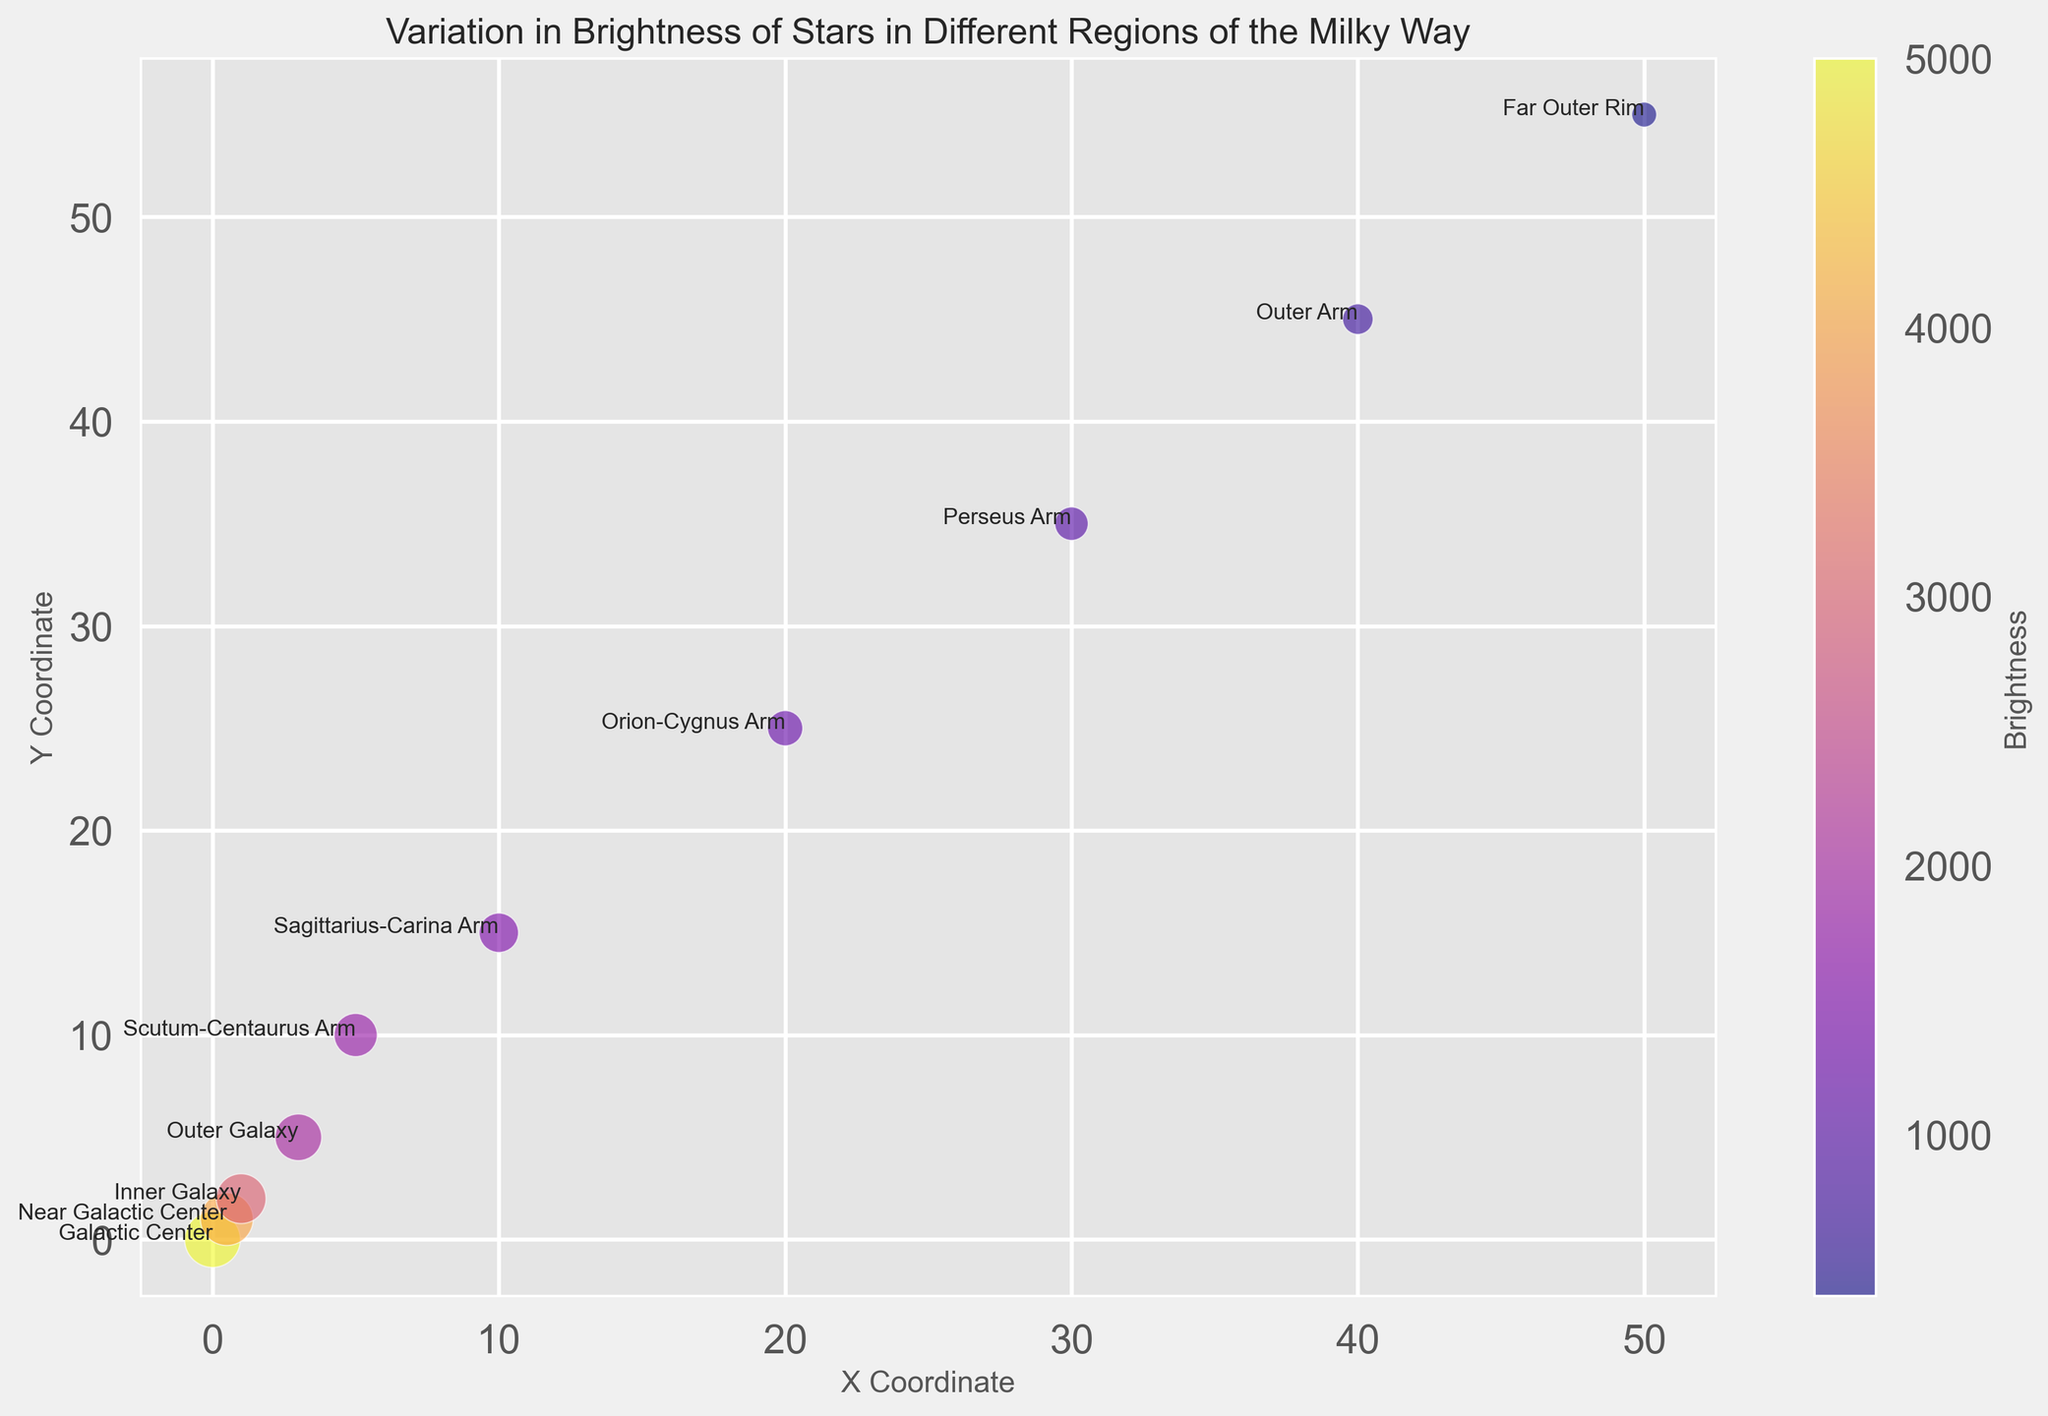Which region has the highest brightness? To find the region with the highest brightness, look for the region where the 'brightness' variable is at its maximum value. From the plot, the brightness is highest at the Galactic Center, which is at the center of the chart.
Answer: Galactic Center Which region occupies the largest bubble on the chart? The size of the bubble is proportional to the 'size' column. Locate the largest bubble visually on the chart, which corresponds to the largest star size. The largest bubble is at the Galactic Center (center of the chart).
Answer: Galactic Center How does the brightness of stars change as you move from the Galactic Center to the Far Outer Rim? Observe the colors of the bubbles as you move from the Galactic Center to the Far Outer Rim. The colors shift from a bright yellow (high brightness) at the Galactic Center to darker colors (lower brightness) at the Far Outer Rim. This indicates a decrease in brightness.
Answer: Decreases Compare the brightness of stars between the Inner Galaxy and the Scutum-Centaurus Arm. Which is brighter? Find the Inner Galaxy and the Scutum-Centaurus Arm on the chart. Compare their colors; the Inner Galaxy has a brighter color (higher brightness of 3000) compared to the Scutum-Centaurus Arm (brightness of 1800).
Answer: Inner Galaxy What is the average brightness of stars in the Scutum-Centaurus Arm and the Sagittarius-Carina Arm? The brightness values for the Scutum-Centaurus Arm and the Sagittarius-Carina Arm are 1800 and 1500, respectively. Calculate the average: (1800 + 1500) / 2 = 1650.
Answer: 1650 Which region is farthest from the Galactic Center in terms of x and y coordinates? To find the region farthest from the Galactic Center, look for the bubble with the highest x and y coordinates. The Far Outer Rim has the highest x (50) and y (55) coordinates.
Answer: Far Outer Rim Which regions have bubbles that are similar in size? The regions with bubbles close in size are 'Inner Galaxy' (size 40) and 'Outer Galaxy' (size 35) because their bubble sizes are visually similar.
Answer: Inner Galaxy and Outer Galaxy Are the larger bubbles generally brighter? Visually observe if the larger bubbles (bigger size) correspond to brighter colors (higher brightness). Larger bubbles such as those at the Galactic Center and Near Galactic Center are brighter, confirming a general trend where larger bubbles are brighter.
Answer: Yes 